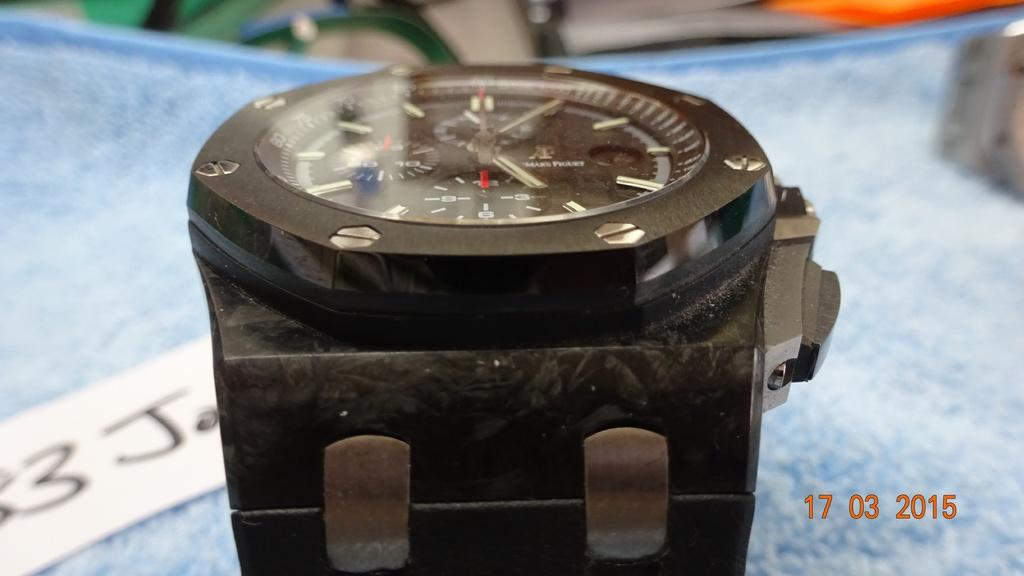<image>
Share a concise interpretation of the image provided. A photo of a black wrist watch was taken on March 17, 2015. 